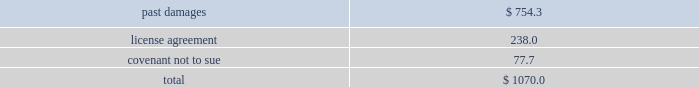Edwards lifesciences corporation notes to consolidated financial statements ( continued ) 2 .
Summary of significant accounting policies ( continued ) in may 2014 , the fasb issued an update to the accounting guidance on revenue recognition .
The new guidance provides a comprehensive , principles-based approach to revenue recognition , and supersedes most previous revenue recognition guidance .
The core principle of the guidance is that an entity should recognize revenue to depict the transfer of promised goods or services to customers in an amount that reflects the consideration to which the entity expects to be entitled in exchange for those goods or services .
The guidance also requires improved disclosures on the nature , amount , timing , and uncertainty of revenue that is recognized .
In august 2015 , the fasb issued an update to the guidance to defer the effective date by one year , such that the new standard will be effective for annual reporting periods beginning after december 15 , 2017 and interim periods therein .
The new guidance can be applied retrospectively to each prior reporting period presented , or retrospectively with the cumulative effect of the change recognized at the date of the initial application .
The company is assessing all of the potential impacts of the revenue recognition guidance and has not yet selected an adoption method .
The company will adopt the new guidance effective january 1 , although the company has not yet completed its assessment of the new revenue recognition guidance , the company 2019s analysis of contracts related to the sale of its heart valve therapy products under the new revenue recognition guidance supports the recognition of revenue at a point-in-time , which is consistent with its current revenue recognition model .
Heart valve therapy sales accounted for approximately 80% ( 80 % ) of the company 2019s sales for the year ended december 31 , 2016 .
The company is currently assessing the potential impact of the guidance on contracts related to the sale of its critical care products , specifically sales outside of the united states .
Intellectual property litigation expenses ( income ) , net in may 2014 , the company entered into an agreement with medtronic , inc .
And its affiliates ( 2018 2018medtronic 2019 2019 ) to settle all outstanding patent litigation between the companies , including all cases related to transcatheter heart valves .
Pursuant to the agreement , all pending cases or appeals in courts and patent offices worldwide have been dismissed , and the parties will not litigate patent disputes with each other in the field of transcatheter valves for the eight-year term of the agreement .
Under the terms of a patent cross-license that is part of the agreement , medtronic made a one-time , upfront payment to the company for past damages in the amount of $ 750.0 million .
In addition , medtronic will pay the company quarterly license royalty payments through april 2022 .
For sales in the united states , subject to certain conditions , the royalty payments will be based on a percentage of medtronic 2019s sales of transcatheter aortic valves , with a minimum annual payment of $ 40.0 million and a maximum annual payment of $ 60.0 million .
A separate royalty payment will be calculated based on sales of medtronic transcatheter aortic valves manufactured in the united states but sold elsewhere .
The company accounted for the settlement agreement as a multiple-element arrangement and allocated the total consideration to the identifiable elements based upon their relative fair value .
The consideration assigned to each element was as follows ( in millions ) : .

What percentage of the settlement was due to license agreements? 
Computations: (238.0 / 1070.0)
Answer: 0.22243. 